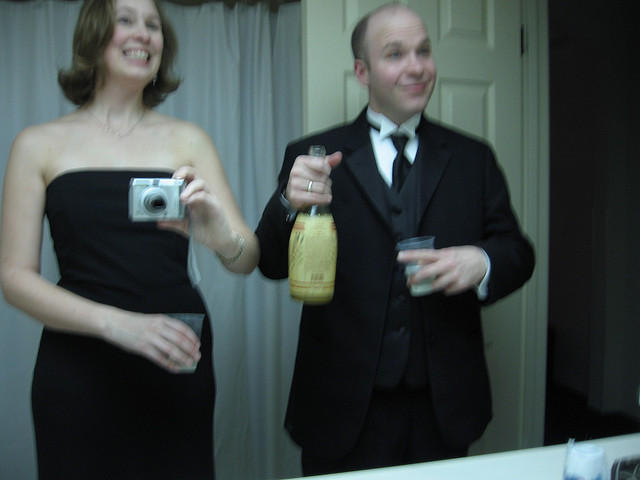<image>What fingers are pointing? I am unsure what fingers are pointing. It could be the middle, the index, the thumb or none. What fingers are pointing? It is ambiguous what fingers are pointing. It can be seen the middle, index and middle, thumb and index, or index and middle fingers. 